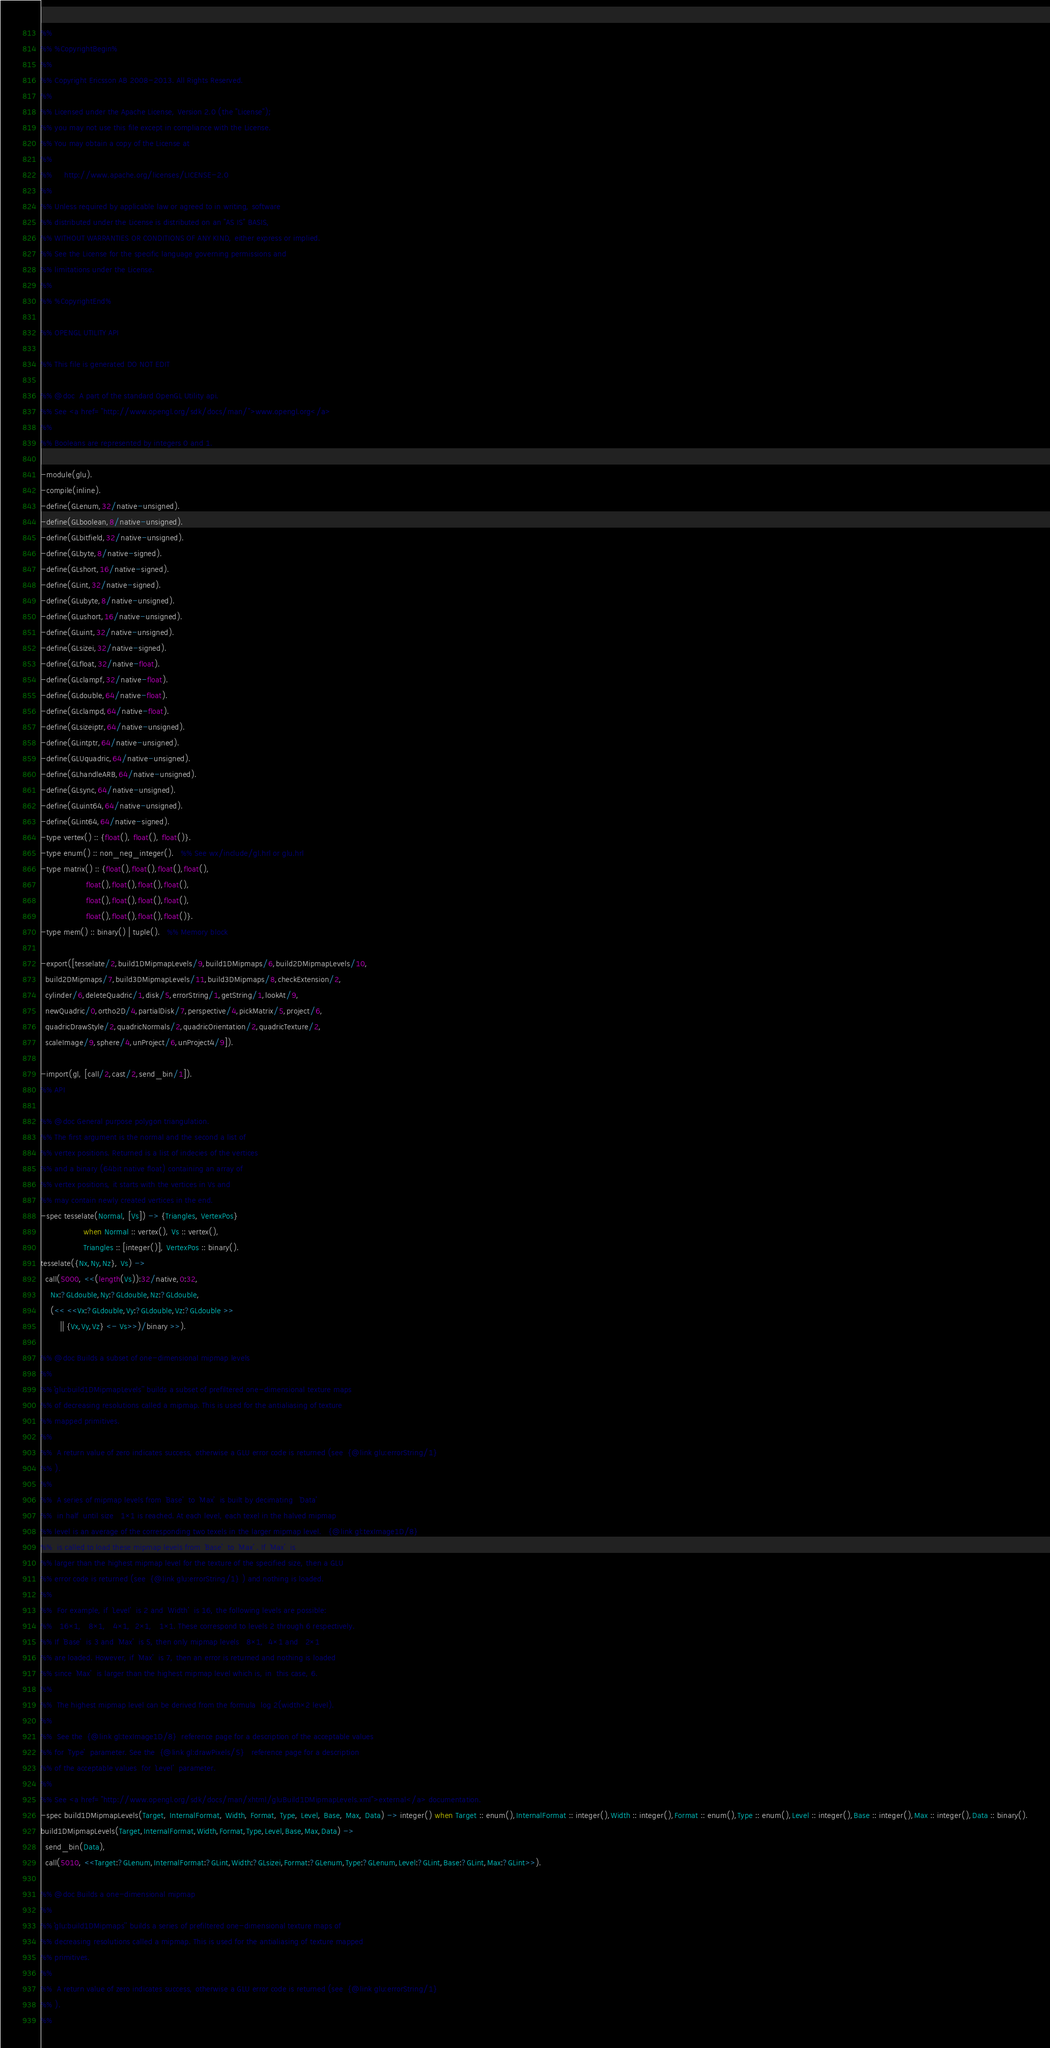Convert code to text. <code><loc_0><loc_0><loc_500><loc_500><_Erlang_>%%
%% %CopyrightBegin%
%%
%% Copyright Ericsson AB 2008-2013. All Rights Reserved.
%%
%% Licensed under the Apache License, Version 2.0 (the "License");
%% you may not use this file except in compliance with the License.
%% You may obtain a copy of the License at
%%
%%     http://www.apache.org/licenses/LICENSE-2.0
%%
%% Unless required by applicable law or agreed to in writing, software
%% distributed under the License is distributed on an "AS IS" BASIS,
%% WITHOUT WARRANTIES OR CONDITIONS OF ANY KIND, either express or implied.
%% See the License for the specific language governing permissions and
%% limitations under the License.
%%
%% %CopyrightEnd%

%% OPENGL UTILITY API

%% This file is generated DO NOT EDIT

%% @doc  A part of the standard OpenGL Utility api.
%% See <a href="http://www.opengl.org/sdk/docs/man/">www.opengl.org</a>
%%
%% Booleans are represented by integers 0 and 1.

-module(glu).
-compile(inline).
-define(GLenum,32/native-unsigned).
-define(GLboolean,8/native-unsigned).
-define(GLbitfield,32/native-unsigned).
-define(GLbyte,8/native-signed).
-define(GLshort,16/native-signed).
-define(GLint,32/native-signed).
-define(GLubyte,8/native-unsigned).
-define(GLushort,16/native-unsigned).
-define(GLuint,32/native-unsigned).
-define(GLsizei,32/native-signed).
-define(GLfloat,32/native-float).
-define(GLclampf,32/native-float).
-define(GLdouble,64/native-float).
-define(GLclampd,64/native-float).
-define(GLsizeiptr,64/native-unsigned).
-define(GLintptr,64/native-unsigned).
-define(GLUquadric,64/native-unsigned).
-define(GLhandleARB,64/native-unsigned).
-define(GLsync,64/native-unsigned).
-define(GLuint64,64/native-unsigned).
-define(GLint64,64/native-signed).
-type vertex() :: {float(), float(), float()}.
-type enum() :: non_neg_integer().   %% See wx/include/gl.hrl or glu.hrl
-type matrix() :: {float(),float(),float(),float(),
                   float(),float(),float(),float(),
                   float(),float(),float(),float(),
                   float(),float(),float(),float()}.
-type mem() :: binary() | tuple().   %% Memory block

-export([tesselate/2,build1DMipmapLevels/9,build1DMipmaps/6,build2DMipmapLevels/10,
  build2DMipmaps/7,build3DMipmapLevels/11,build3DMipmaps/8,checkExtension/2,
  cylinder/6,deleteQuadric/1,disk/5,errorString/1,getString/1,lookAt/9,
  newQuadric/0,ortho2D/4,partialDisk/7,perspective/4,pickMatrix/5,project/6,
  quadricDrawStyle/2,quadricNormals/2,quadricOrientation/2,quadricTexture/2,
  scaleImage/9,sphere/4,unProject/6,unProject4/9]).

-import(gl, [call/2,cast/2,send_bin/1]).
%% API

%% @doc General purpose polygon triangulation.
%% The first argument is the normal and the second a list of
%% vertex positions. Returned is a list of indecies of the vertices
%% and a binary (64bit native float) containing an array of
%% vertex positions, it starts with the vertices in Vs and
%% may contain newly created vertices in the end.
-spec tesselate(Normal, [Vs]) -> {Triangles, VertexPos}
                  when Normal :: vertex(), Vs :: vertex(),
                  Triangles :: [integer()], VertexPos :: binary().
tesselate({Nx,Ny,Nz}, Vs) ->
  call(5000, <<(length(Vs)):32/native,0:32,
    Nx:?GLdouble,Ny:?GLdouble,Nz:?GLdouble,
    (<< <<Vx:?GLdouble,Vy:?GLdouble,Vz:?GLdouble >>
        || {Vx,Vy,Vz} <- Vs>>)/binary >>).

%% @doc Builds a subset of one-dimensional mipmap levels
%%
%% ``glu:build1DMipmapLevels'' builds a subset of prefiltered one-dimensional texture maps
%% of decreasing resolutions called a mipmap. This is used for the antialiasing of texture
%% mapped primitives. 
%%
%%  A return value of zero indicates success, otherwise a GLU error code is returned (see  {@link glu:errorString/1} 
%% ). 
%%
%%  A series of mipmap levels from  `Base'  to  `Max'  is built by decimating   `Data' 
%%  in half  until size   1×1 is reached. At each level, each texel in the halved mipmap
%% level is an average of the corresponding two texels in the larger mipmap level.   {@link gl:texImage1D/8} 
%%  is called to load these mipmap levels from  `Base'  to  `Max' . If  `Max'  is
%% larger than the highest mipmap level for the texture of the specified size, then a GLU
%% error code is returned (see  {@link glu:errorString/1} ) and nothing is loaded. 
%%
%%  For example, if  `Level'  is 2 and  `Width'  is 16, the following levels are possible:
%%   16×1,   8×1,   4×1,  2×1,   1×1. These correspond to levels 2 through 6 respectively.
%% If  `Base'  is 3 and  `Max'  is 5, then only mipmap levels   8×1,  4×1 and   2×1
%% are loaded. However, if  `Max'  is 7, then an error is returned and nothing is loaded
%% since  `Max'  is larger than the highest mipmap level which is, in  this case, 6. 
%%
%%  The highest mipmap level can be derived from the formula  log 2(width×2 level). 
%%
%%  See the  {@link gl:texImage1D/8}  reference page for a description of the acceptable values
%% for  `Type'  parameter. See the  {@link gl:drawPixels/5}   reference page for a description
%% of the acceptable values  for  `Level'  parameter. 
%%
%% See <a href="http://www.opengl.org/sdk/docs/man/xhtml/gluBuild1DMipmapLevels.xml">external</a> documentation.
-spec build1DMipmapLevels(Target, InternalFormat, Width, Format, Type, Level, Base, Max, Data) -> integer() when Target :: enum(),InternalFormat :: integer(),Width :: integer(),Format :: enum(),Type :: enum(),Level :: integer(),Base :: integer(),Max :: integer(),Data :: binary().
build1DMipmapLevels(Target,InternalFormat,Width,Format,Type,Level,Base,Max,Data) ->
  send_bin(Data),
  call(5010, <<Target:?GLenum,InternalFormat:?GLint,Width:?GLsizei,Format:?GLenum,Type:?GLenum,Level:?GLint,Base:?GLint,Max:?GLint>>).

%% @doc Builds a one-dimensional mipmap
%%
%% ``glu:build1DMipmaps'' builds a series of prefiltered one-dimensional texture maps of
%% decreasing resolutions called a mipmap. This is used for the antialiasing of texture mapped
%% primitives. 
%%
%%  A return value of zero indicates success, otherwise a GLU error code is returned (see  {@link glu:errorString/1} 
%% ). 
%%</code> 